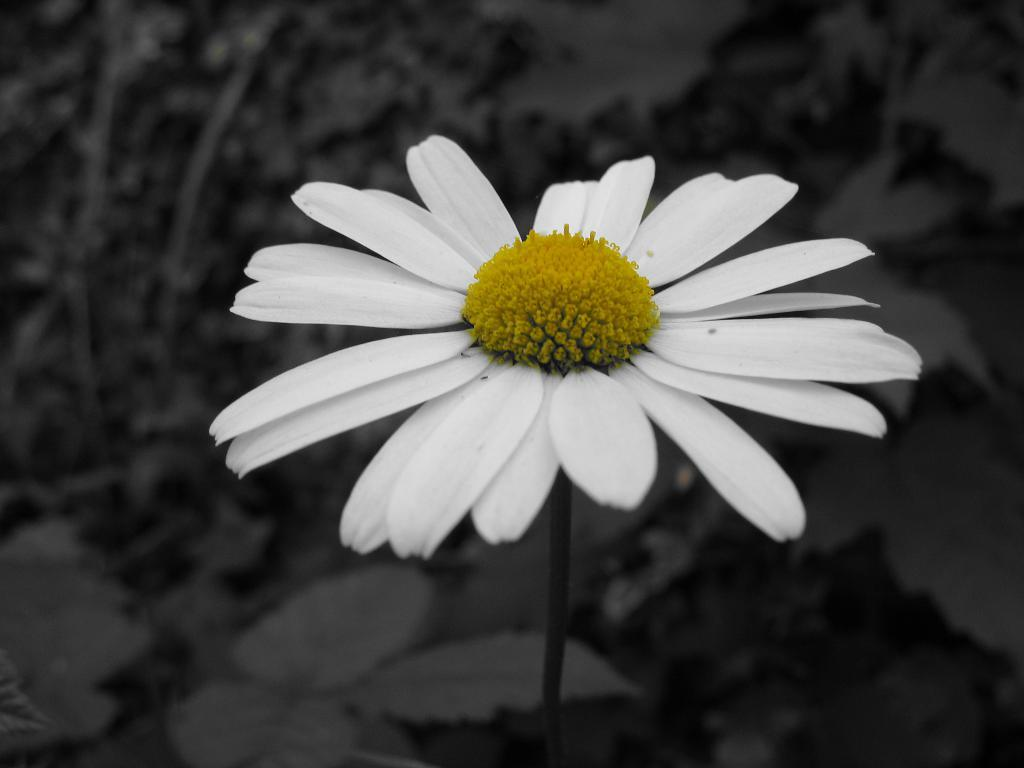What can be observed about the image? The image is edited. What type of object or living organism is present in the image? There is a flower in the image. How many bears can be seen interacting with the flower in the image? There are no bears present in the image; it only features a flower. 